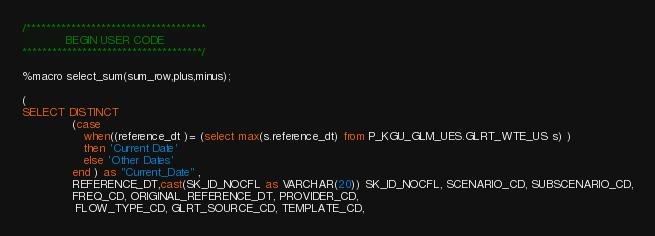<code> <loc_0><loc_0><loc_500><loc_500><_SQL_>/************************************
			BEGIN USER CODE 
************************************/

%macro select_sum(sum_row,plus,minus);

(
SELECT DISTINCT   
              (case 
                 when((reference_dt )= (select max(s.reference_dt) from P_KGU_GLM_UES.GLRT_WTE_US s) )
                 then 'Current Date'
                 else 'Other Dates'
              end ) as "Current_Date" ,
              REFERENCE_DT,cast(SK_ID_NOCFL as VARCHAR(20)) SK_ID_NOCFL, SCENARIO_CD, SUBSCENARIO_CD,
              FREQ_CD, ORIGINAL_REFERENCE_DT, PROVIDER_CD, 
               FLOW_TYPE_CD, GLRT_SOURCE_CD, TEMPLATE_CD, </code> 